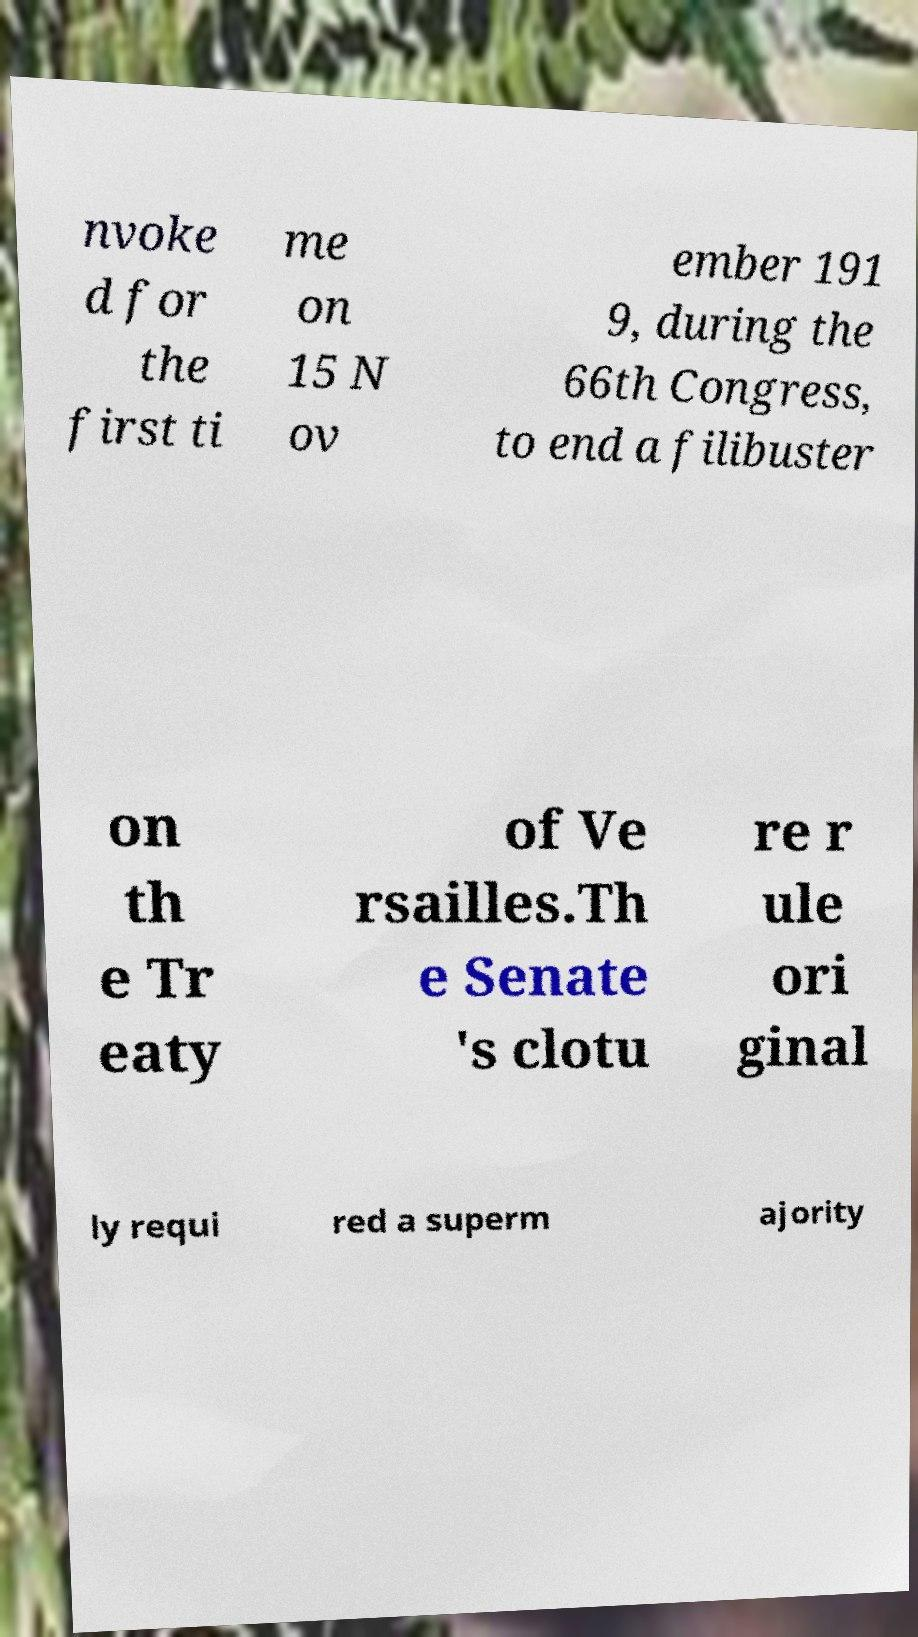Could you extract and type out the text from this image? nvoke d for the first ti me on 15 N ov ember 191 9, during the 66th Congress, to end a filibuster on th e Tr eaty of Ve rsailles.Th e Senate 's clotu re r ule ori ginal ly requi red a superm ajority 